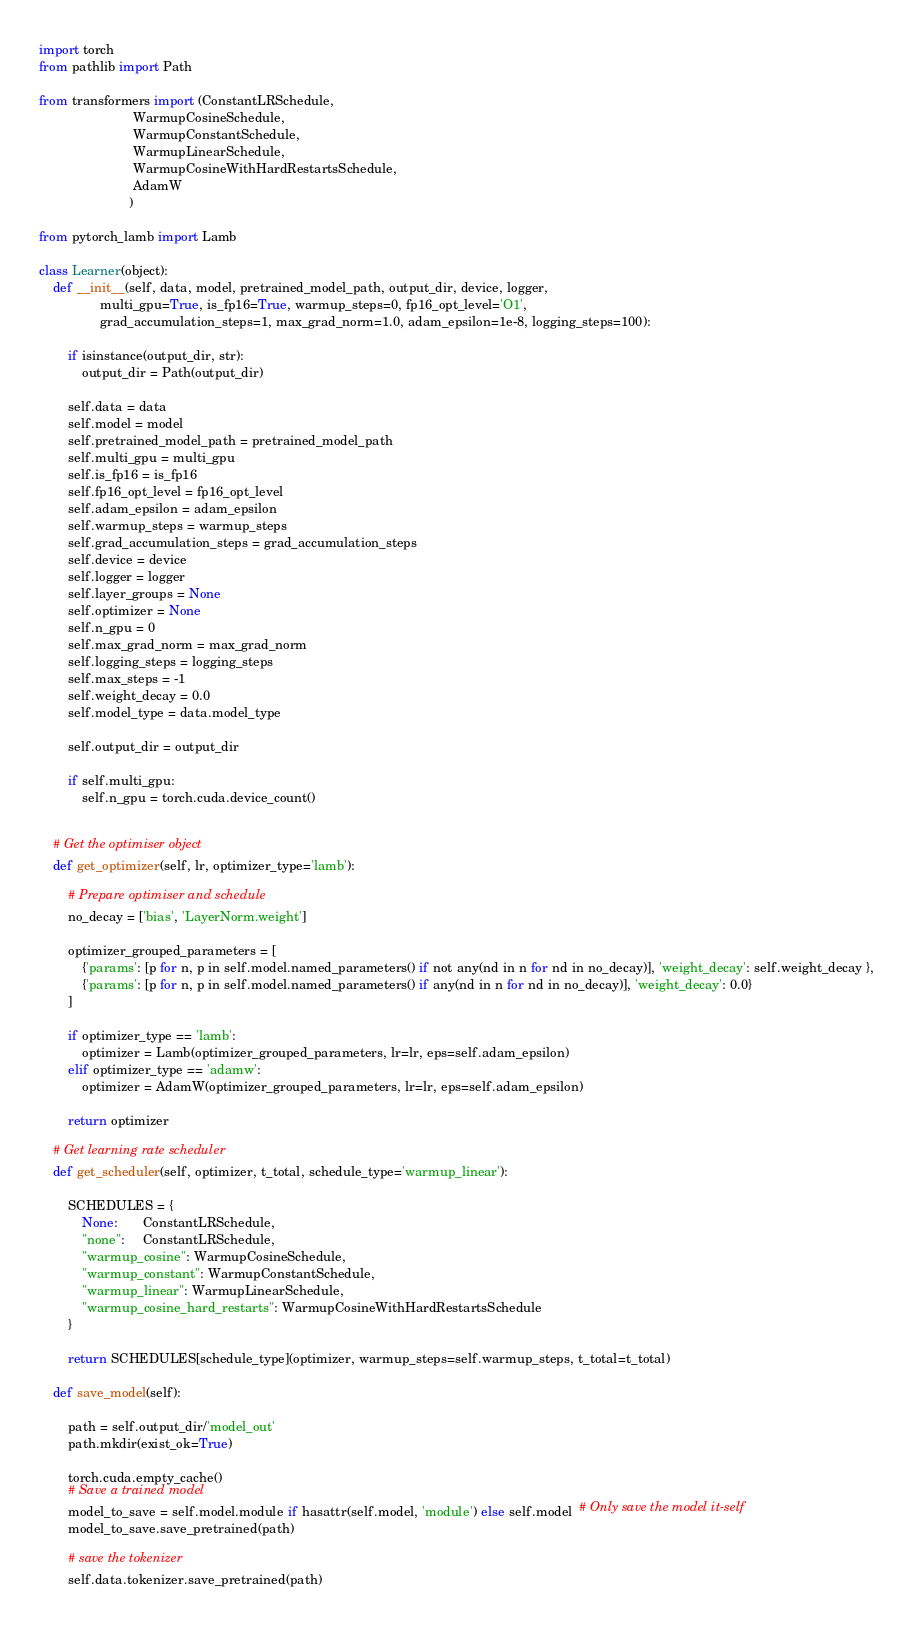Convert code to text. <code><loc_0><loc_0><loc_500><loc_500><_Python_>import torch
from pathlib import Path

from transformers import (ConstantLRSchedule,
                          WarmupCosineSchedule, 
                          WarmupConstantSchedule, 
                          WarmupLinearSchedule, 
                          WarmupCosineWithHardRestartsSchedule,
                          AdamW
                         )

from pytorch_lamb import Lamb

class Learner(object):
    def __init__(self, data, model, pretrained_model_path, output_dir, device, logger,
                 multi_gpu=True, is_fp16=True, warmup_steps=0, fp16_opt_level='O1',
                 grad_accumulation_steps=1, max_grad_norm=1.0, adam_epsilon=1e-8, logging_steps=100):
        
        if isinstance(output_dir, str):
            output_dir = Path(output_dir)
        
        self.data = data
        self.model = model
        self.pretrained_model_path = pretrained_model_path
        self.multi_gpu = multi_gpu
        self.is_fp16 = is_fp16
        self.fp16_opt_level = fp16_opt_level
        self.adam_epsilon = adam_epsilon
        self.warmup_steps = warmup_steps
        self.grad_accumulation_steps = grad_accumulation_steps
        self.device = device
        self.logger = logger
        self.layer_groups = None
        self.optimizer = None
        self.n_gpu = 0
        self.max_grad_norm = max_grad_norm
        self.logging_steps = logging_steps
        self.max_steps = -1
        self.weight_decay = 0.0
        self.model_type = data.model_type
        
        self.output_dir = output_dir
        
        if self.multi_gpu:
            self.n_gpu = torch.cuda.device_count()
              

    # Get the optimiser object
    def get_optimizer(self, lr, optimizer_type='lamb'):       

        # Prepare optimiser and schedule 
        no_decay = ['bias', 'LayerNorm.weight']

        optimizer_grouped_parameters = [
            {'params': [p for n, p in self.model.named_parameters() if not any(nd in n for nd in no_decay)], 'weight_decay': self.weight_decay },
            {'params': [p for n, p in self.model.named_parameters() if any(nd in n for nd in no_decay)], 'weight_decay': 0.0}
        ]

        if optimizer_type == 'lamb':
            optimizer = Lamb(optimizer_grouped_parameters, lr=lr, eps=self.adam_epsilon)
        elif optimizer_type == 'adamw':
            optimizer = AdamW(optimizer_grouped_parameters, lr=lr, eps=self.adam_epsilon)

        return optimizer

    # Get learning rate scheduler
    def get_scheduler(self, optimizer, t_total, schedule_type='warmup_linear'):

        SCHEDULES = {
            None:       ConstantLRSchedule,
            "none":     ConstantLRSchedule,
            "warmup_cosine": WarmupCosineSchedule,
            "warmup_constant": WarmupConstantSchedule,
            "warmup_linear": WarmupLinearSchedule,
            "warmup_cosine_hard_restarts": WarmupCosineWithHardRestartsSchedule
        }

        return SCHEDULES[schedule_type](optimizer, warmup_steps=self.warmup_steps, t_total=t_total)
    
    def save_model(self): 
        
        path = self.output_dir/'model_out'
        path.mkdir(exist_ok=True)
        
        torch.cuda.empty_cache() 
        # Save a trained model
        model_to_save = self.model.module if hasattr(self.model, 'module') else self.model  # Only save the model it-self
        model_to_save.save_pretrained(path)
        
        # save the tokenizer
        self.data.tokenizer.save_pretrained(path)</code> 